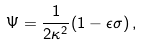Convert formula to latex. <formula><loc_0><loc_0><loc_500><loc_500>\Psi = \frac { 1 } { 2 \kappa ^ { 2 } } ( 1 - \epsilon \sigma ) \, ,</formula> 